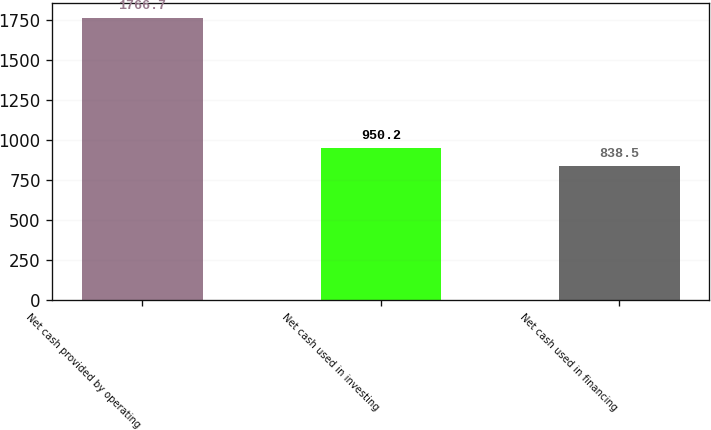Convert chart. <chart><loc_0><loc_0><loc_500><loc_500><bar_chart><fcel>Net cash provided by operating<fcel>Net cash used in investing<fcel>Net cash used in financing<nl><fcel>1766.7<fcel>950.2<fcel>838.5<nl></chart> 